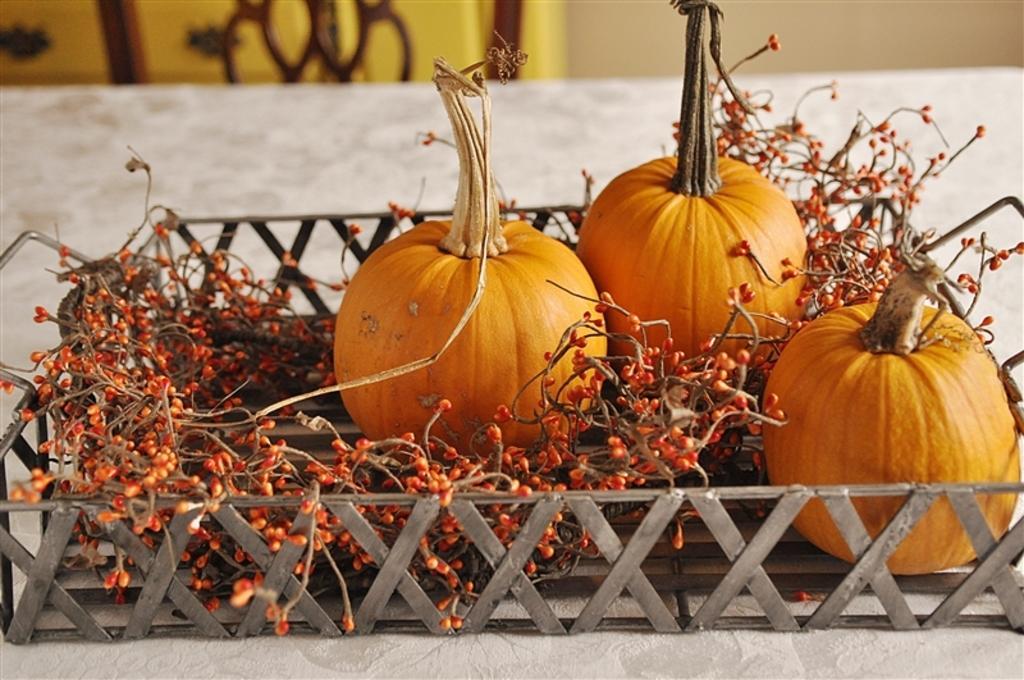Could you give a brief overview of what you see in this image? The picture consists of pumpkins and berries placed in a tray. The tray is placed on a table covered with cloth. At the top it is blurred. 